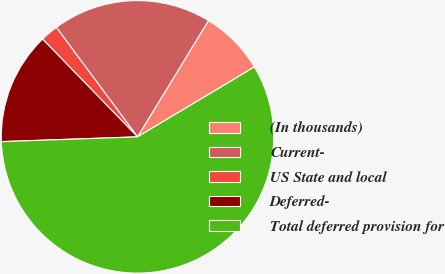Convert chart to OTSL. <chart><loc_0><loc_0><loc_500><loc_500><pie_chart><fcel>(In thousands)<fcel>Current-<fcel>US State and local<fcel>Deferred-<fcel>Total deferred provision for<nl><fcel>7.7%<fcel>18.88%<fcel>2.11%<fcel>13.29%<fcel>58.01%<nl></chart> 